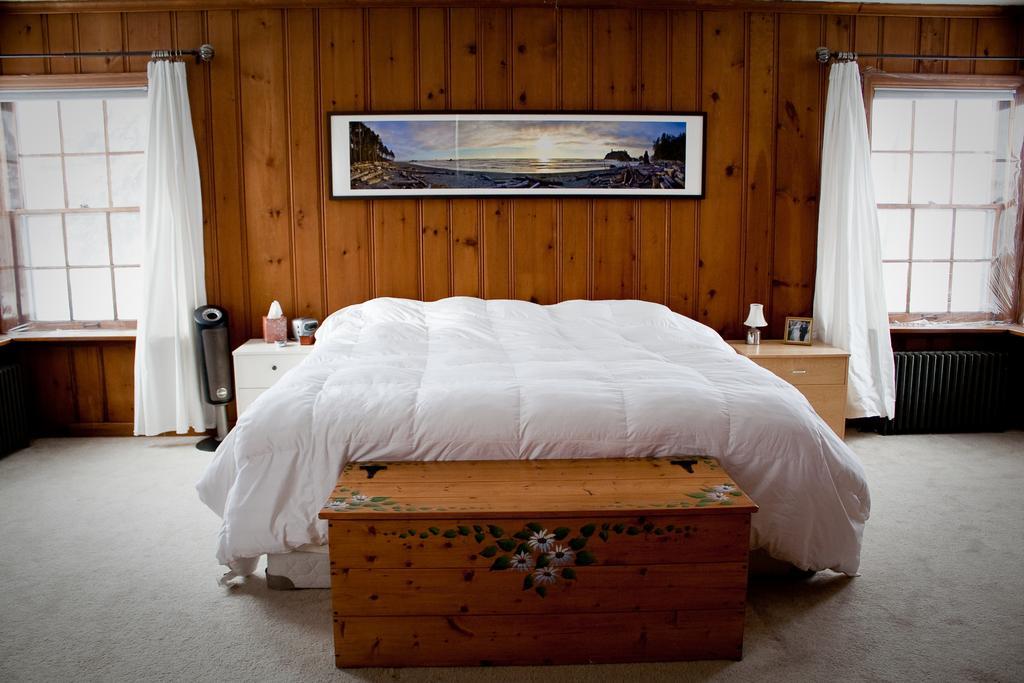Please provide a concise description of this image. In the middle of the image, there is a bed having white color bed sheet. Beside this bed, there is a wooden box and there are some objects on the cupboards. In the background, there is a photo frame on the wooden wall and there are two windows which are having white color curtains. 